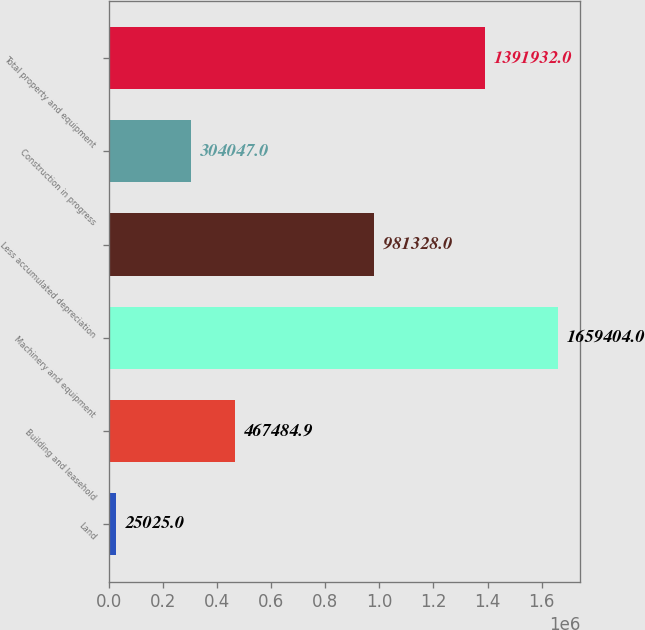Convert chart. <chart><loc_0><loc_0><loc_500><loc_500><bar_chart><fcel>Land<fcel>Building and leasehold<fcel>Machinery and equipment<fcel>Less accumulated depreciation<fcel>Construction in progress<fcel>Total property and equipment<nl><fcel>25025<fcel>467485<fcel>1.6594e+06<fcel>981328<fcel>304047<fcel>1.39193e+06<nl></chart> 